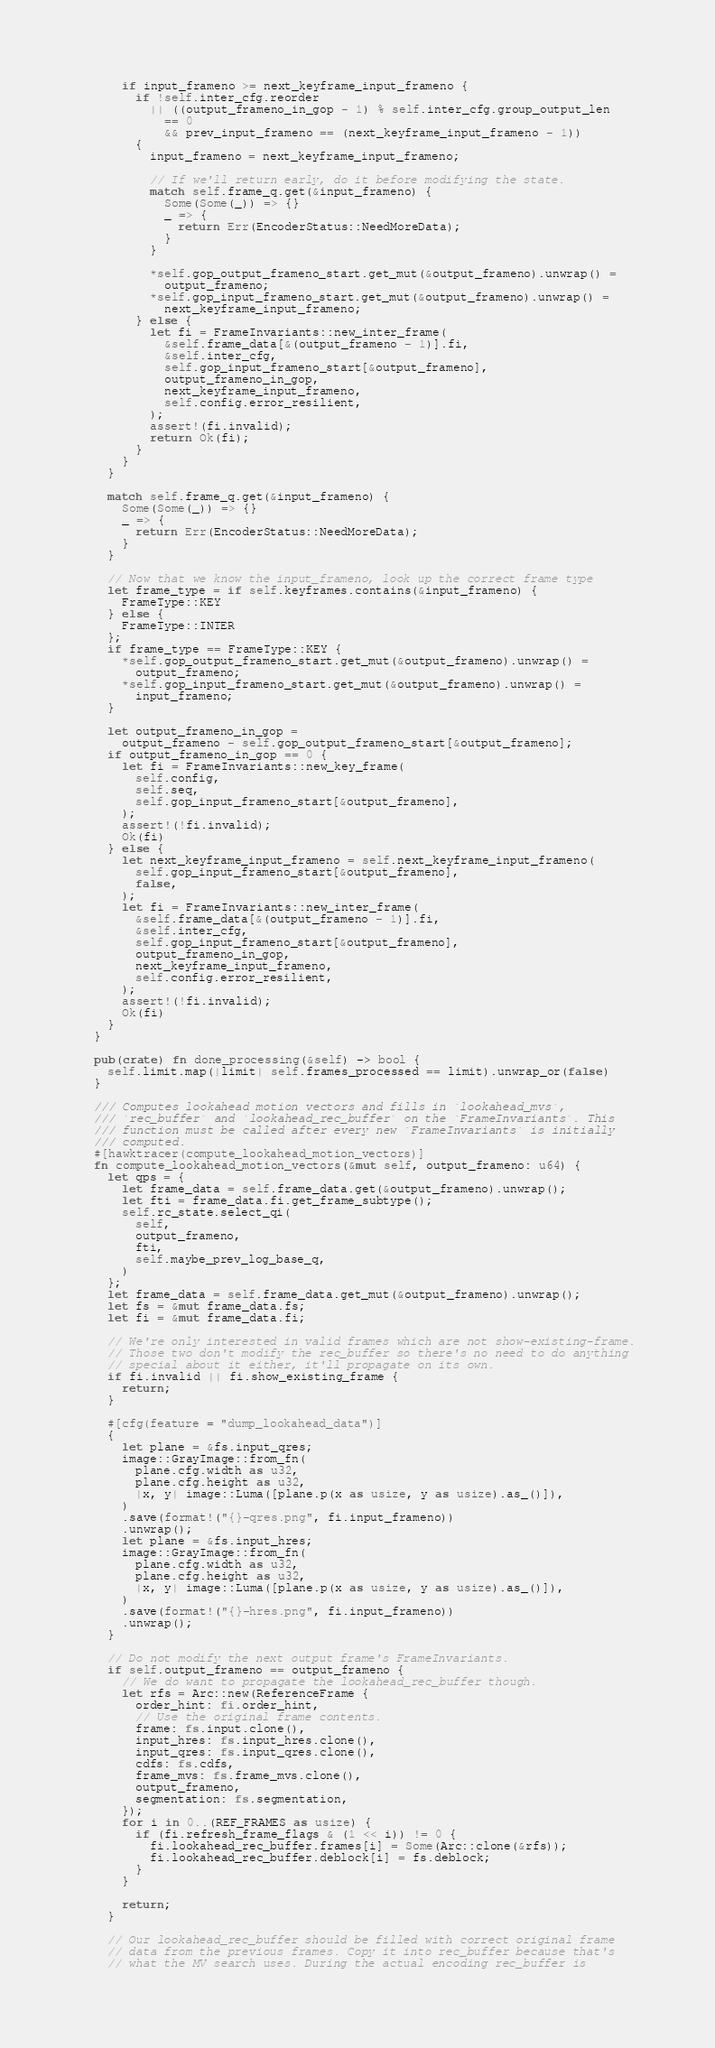Convert code to text. <code><loc_0><loc_0><loc_500><loc_500><_Rust_>      if input_frameno >= next_keyframe_input_frameno {
        if !self.inter_cfg.reorder
          || ((output_frameno_in_gop - 1) % self.inter_cfg.group_output_len
            == 0
            && prev_input_frameno == (next_keyframe_input_frameno - 1))
        {
          input_frameno = next_keyframe_input_frameno;

          // If we'll return early, do it before modifying the state.
          match self.frame_q.get(&input_frameno) {
            Some(Some(_)) => {}
            _ => {
              return Err(EncoderStatus::NeedMoreData);
            }
          }

          *self.gop_output_frameno_start.get_mut(&output_frameno).unwrap() =
            output_frameno;
          *self.gop_input_frameno_start.get_mut(&output_frameno).unwrap() =
            next_keyframe_input_frameno;
        } else {
          let fi = FrameInvariants::new_inter_frame(
            &self.frame_data[&(output_frameno - 1)].fi,
            &self.inter_cfg,
            self.gop_input_frameno_start[&output_frameno],
            output_frameno_in_gop,
            next_keyframe_input_frameno,
            self.config.error_resilient,
          );
          assert!(fi.invalid);
          return Ok(fi);
        }
      }
    }

    match self.frame_q.get(&input_frameno) {
      Some(Some(_)) => {}
      _ => {
        return Err(EncoderStatus::NeedMoreData);
      }
    }

    // Now that we know the input_frameno, look up the correct frame type
    let frame_type = if self.keyframes.contains(&input_frameno) {
      FrameType::KEY
    } else {
      FrameType::INTER
    };
    if frame_type == FrameType::KEY {
      *self.gop_output_frameno_start.get_mut(&output_frameno).unwrap() =
        output_frameno;
      *self.gop_input_frameno_start.get_mut(&output_frameno).unwrap() =
        input_frameno;
    }

    let output_frameno_in_gop =
      output_frameno - self.gop_output_frameno_start[&output_frameno];
    if output_frameno_in_gop == 0 {
      let fi = FrameInvariants::new_key_frame(
        self.config,
        self.seq,
        self.gop_input_frameno_start[&output_frameno],
      );
      assert!(!fi.invalid);
      Ok(fi)
    } else {
      let next_keyframe_input_frameno = self.next_keyframe_input_frameno(
        self.gop_input_frameno_start[&output_frameno],
        false,
      );
      let fi = FrameInvariants::new_inter_frame(
        &self.frame_data[&(output_frameno - 1)].fi,
        &self.inter_cfg,
        self.gop_input_frameno_start[&output_frameno],
        output_frameno_in_gop,
        next_keyframe_input_frameno,
        self.config.error_resilient,
      );
      assert!(!fi.invalid);
      Ok(fi)
    }
  }

  pub(crate) fn done_processing(&self) -> bool {
    self.limit.map(|limit| self.frames_processed == limit).unwrap_or(false)
  }

  /// Computes lookahead motion vectors and fills in `lookahead_mvs`,
  /// `rec_buffer` and `lookahead_rec_buffer` on the `FrameInvariants`. This
  /// function must be called after every new `FrameInvariants` is initially
  /// computed.
  #[hawktracer(compute_lookahead_motion_vectors)]
  fn compute_lookahead_motion_vectors(&mut self, output_frameno: u64) {
    let qps = {
      let frame_data = self.frame_data.get(&output_frameno).unwrap();
      let fti = frame_data.fi.get_frame_subtype();
      self.rc_state.select_qi(
        self,
        output_frameno,
        fti,
        self.maybe_prev_log_base_q,
      )
    };
    let frame_data = self.frame_data.get_mut(&output_frameno).unwrap();
    let fs = &mut frame_data.fs;
    let fi = &mut frame_data.fi;

    // We're only interested in valid frames which are not show-existing-frame.
    // Those two don't modify the rec_buffer so there's no need to do anything
    // special about it either, it'll propagate on its own.
    if fi.invalid || fi.show_existing_frame {
      return;
    }

    #[cfg(feature = "dump_lookahead_data")]
    {
      let plane = &fs.input_qres;
      image::GrayImage::from_fn(
        plane.cfg.width as u32,
        plane.cfg.height as u32,
        |x, y| image::Luma([plane.p(x as usize, y as usize).as_()]),
      )
      .save(format!("{}-qres.png", fi.input_frameno))
      .unwrap();
      let plane = &fs.input_hres;
      image::GrayImage::from_fn(
        plane.cfg.width as u32,
        plane.cfg.height as u32,
        |x, y| image::Luma([plane.p(x as usize, y as usize).as_()]),
      )
      .save(format!("{}-hres.png", fi.input_frameno))
      .unwrap();
    }

    // Do not modify the next output frame's FrameInvariants.
    if self.output_frameno == output_frameno {
      // We do want to propagate the lookahead_rec_buffer though.
      let rfs = Arc::new(ReferenceFrame {
        order_hint: fi.order_hint,
        // Use the original frame contents.
        frame: fs.input.clone(),
        input_hres: fs.input_hres.clone(),
        input_qres: fs.input_qres.clone(),
        cdfs: fs.cdfs,
        frame_mvs: fs.frame_mvs.clone(),
        output_frameno,
        segmentation: fs.segmentation,
      });
      for i in 0..(REF_FRAMES as usize) {
        if (fi.refresh_frame_flags & (1 << i)) != 0 {
          fi.lookahead_rec_buffer.frames[i] = Some(Arc::clone(&rfs));
          fi.lookahead_rec_buffer.deblock[i] = fs.deblock;
        }
      }

      return;
    }

    // Our lookahead_rec_buffer should be filled with correct original frame
    // data from the previous frames. Copy it into rec_buffer because that's
    // what the MV search uses. During the actual encoding rec_buffer is</code> 